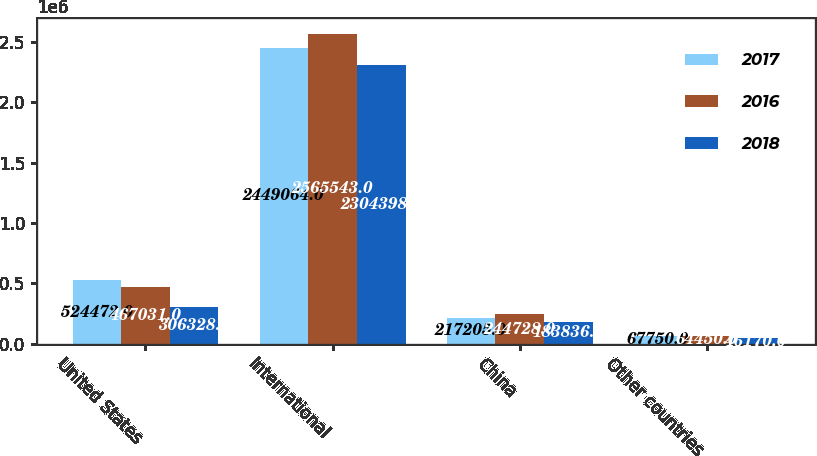Convert chart to OTSL. <chart><loc_0><loc_0><loc_500><loc_500><stacked_bar_chart><ecel><fcel>United States<fcel>International<fcel>China<fcel>Other countries<nl><fcel>2017<fcel>524472<fcel>2.44906e+06<fcel>217205<fcel>67750<nl><fcel>2016<fcel>467031<fcel>2.56554e+06<fcel>244728<fcel>64450<nl><fcel>2018<fcel>306328<fcel>2.3044e+06<fcel>183836<fcel>46170<nl></chart> 